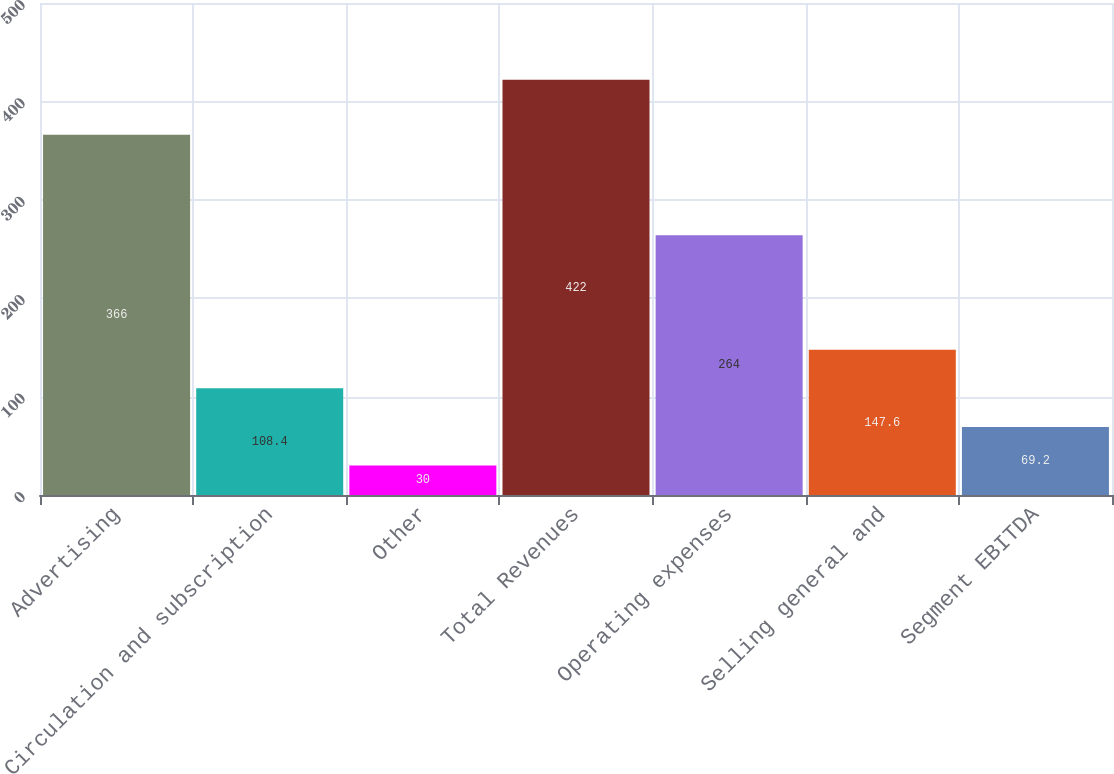<chart> <loc_0><loc_0><loc_500><loc_500><bar_chart><fcel>Advertising<fcel>Circulation and subscription<fcel>Other<fcel>Total Revenues<fcel>Operating expenses<fcel>Selling general and<fcel>Segment EBITDA<nl><fcel>366<fcel>108.4<fcel>30<fcel>422<fcel>264<fcel>147.6<fcel>69.2<nl></chart> 